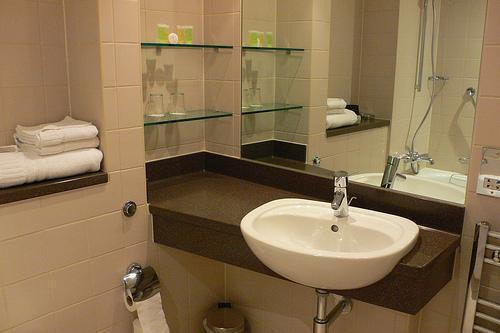How many sinks are there?
Give a very brief answer. 1. 